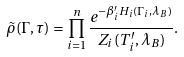<formula> <loc_0><loc_0><loc_500><loc_500>\tilde { \rho } ( \Gamma , \tau ) = \prod _ { i = 1 } ^ { n } \frac { e ^ { - \beta _ { i } ^ { \prime } H _ { i } ( \Gamma _ { i } , \lambda _ { B } ) } } { Z _ { i } ( T ^ { \prime } _ { i } , \lambda _ { B } ) } .</formula> 